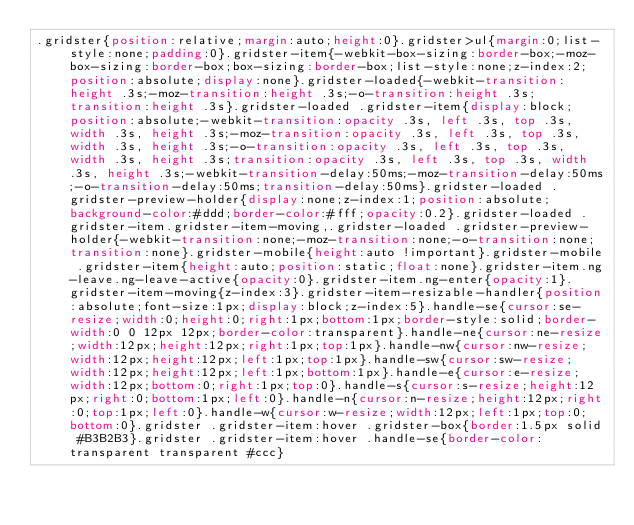<code> <loc_0><loc_0><loc_500><loc_500><_CSS_>.gridster{position:relative;margin:auto;height:0}.gridster>ul{margin:0;list-style:none;padding:0}.gridster-item{-webkit-box-sizing:border-box;-moz-box-sizing:border-box;box-sizing:border-box;list-style:none;z-index:2;position:absolute;display:none}.gridster-loaded{-webkit-transition:height .3s;-moz-transition:height .3s;-o-transition:height .3s;transition:height .3s}.gridster-loaded .gridster-item{display:block;position:absolute;-webkit-transition:opacity .3s, left .3s, top .3s, width .3s, height .3s;-moz-transition:opacity .3s, left .3s, top .3s, width .3s, height .3s;-o-transition:opacity .3s, left .3s, top .3s, width .3s, height .3s;transition:opacity .3s, left .3s, top .3s, width .3s, height .3s;-webkit-transition-delay:50ms;-moz-transition-delay:50ms;-o-transition-delay:50ms;transition-delay:50ms}.gridster-loaded .gridster-preview-holder{display:none;z-index:1;position:absolute;background-color:#ddd;border-color:#fff;opacity:0.2}.gridster-loaded .gridster-item.gridster-item-moving,.gridster-loaded .gridster-preview-holder{-webkit-transition:none;-moz-transition:none;-o-transition:none;transition:none}.gridster-mobile{height:auto !important}.gridster-mobile .gridster-item{height:auto;position:static;float:none}.gridster-item.ng-leave.ng-leave-active{opacity:0}.gridster-item.ng-enter{opacity:1}.gridster-item-moving{z-index:3}.gridster-item-resizable-handler{position:absolute;font-size:1px;display:block;z-index:5}.handle-se{cursor:se-resize;width:0;height:0;right:1px;bottom:1px;border-style:solid;border-width:0 0 12px 12px;border-color:transparent}.handle-ne{cursor:ne-resize;width:12px;height:12px;right:1px;top:1px}.handle-nw{cursor:nw-resize;width:12px;height:12px;left:1px;top:1px}.handle-sw{cursor:sw-resize;width:12px;height:12px;left:1px;bottom:1px}.handle-e{cursor:e-resize;width:12px;bottom:0;right:1px;top:0}.handle-s{cursor:s-resize;height:12px;right:0;bottom:1px;left:0}.handle-n{cursor:n-resize;height:12px;right:0;top:1px;left:0}.handle-w{cursor:w-resize;width:12px;left:1px;top:0;bottom:0}.gridster .gridster-item:hover .gridster-box{border:1.5px solid #B3B2B3}.gridster .gridster-item:hover .handle-se{border-color:transparent transparent #ccc}
</code> 